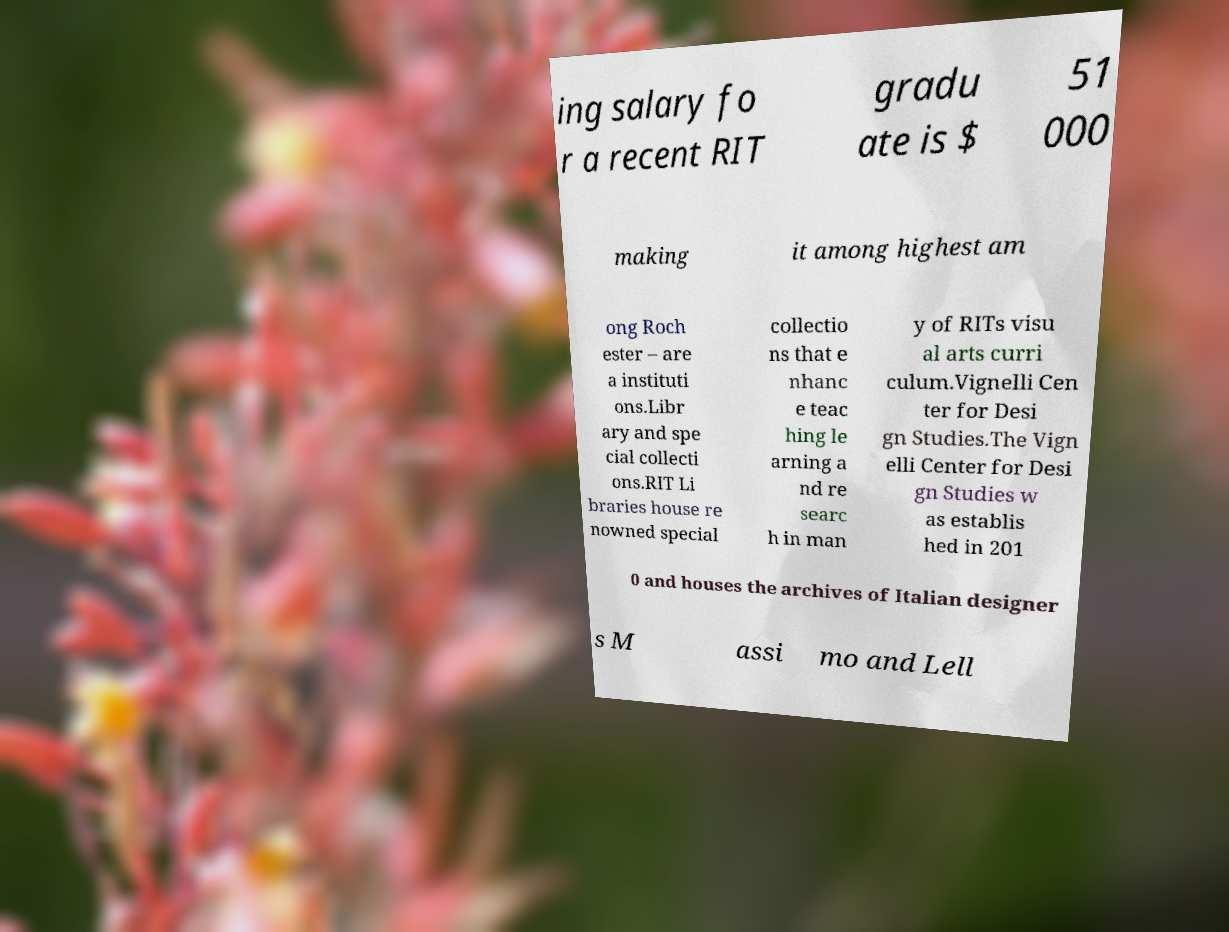Please identify and transcribe the text found in this image. ing salary fo r a recent RIT gradu ate is $ 51 000 making it among highest am ong Roch ester – are a instituti ons.Libr ary and spe cial collecti ons.RIT Li braries house re nowned special collectio ns that e nhanc e teac hing le arning a nd re searc h in man y of RITs visu al arts curri culum.Vignelli Cen ter for Desi gn Studies.The Vign elli Center for Desi gn Studies w as establis hed in 201 0 and houses the archives of Italian designer s M assi mo and Lell 